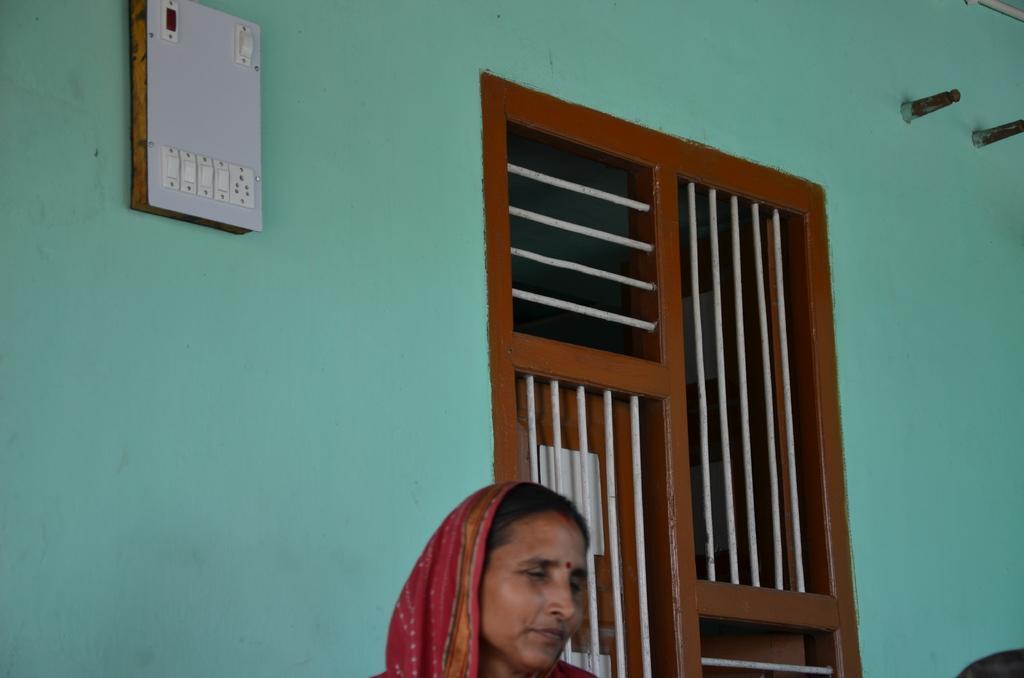How would you summarize this image in a sentence or two? In this image at the bottom there is one woman and in the center there is a window, and on the left side there is a switch board and wall. On the right side there are two bolts. 